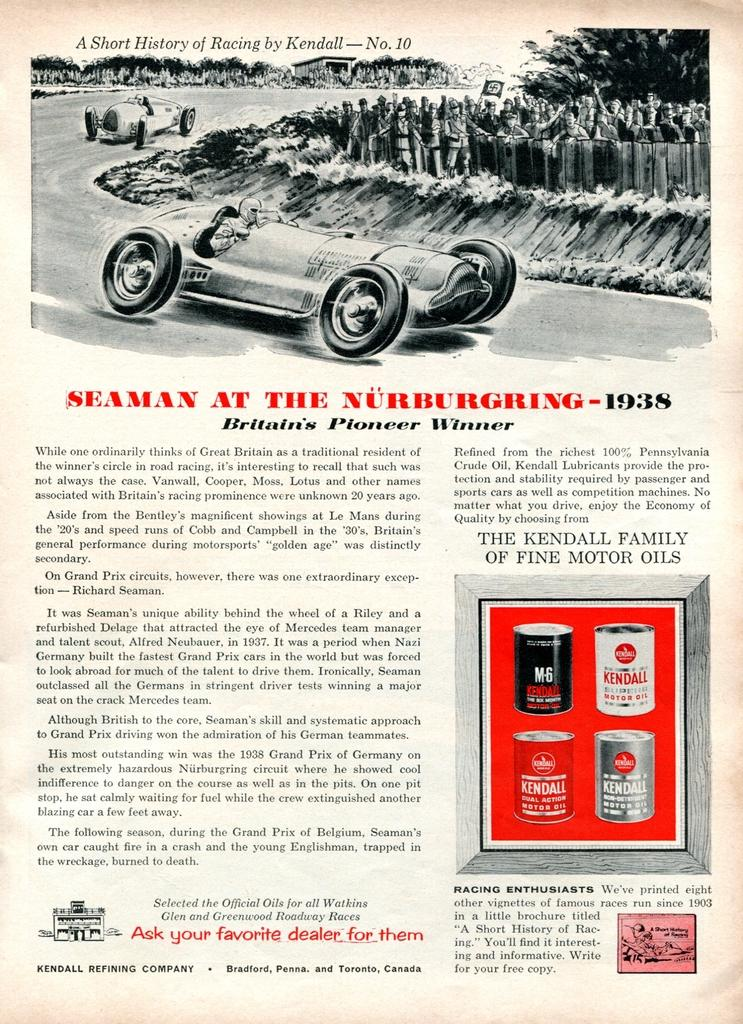What is depicted on the poster in the image? The poster contains vehicles, people, trees, and some information. Can you describe the vehicles on the poster? The poster contains vehicles, but the specific types of vehicles cannot be determined from the provided facts. What else is present on the poster besides vehicles? The poster also contains people and trees. What type of information is present on the poster? The poster contains some information, but the specific details cannot be determined from the provided facts. What color is the skirt worn by the person on the poster? There is no skirt present on the poster; it contains vehicles, people, trees, and information. 